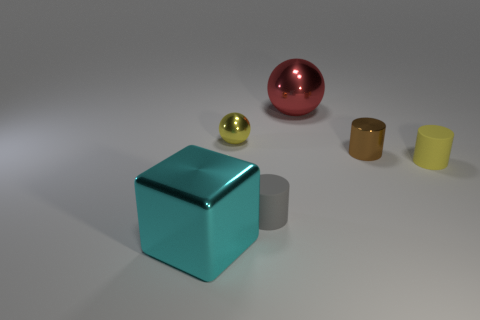What materials do the objects in this image seem to be made of? The objects in this image seem to have different textures and sheens, suggesting they are made from a variety of materials. The sphere has a reflective surface indicative of a metallic finish, possibly steel or aluminum, whereas the cube looks more like a solid plastic or acrylic given its less reflective surface and consistent coloration. The cylinder appears ceramic, with its matte and slightly rough texture. 